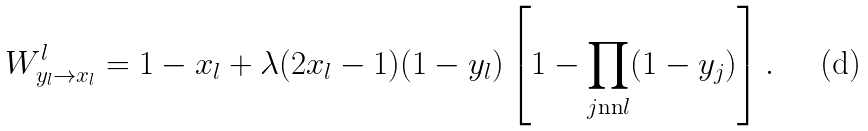<formula> <loc_0><loc_0><loc_500><loc_500>W _ { y _ { l } \rightarrow x _ { l } } ^ { l } = 1 - x _ { l } + \lambda ( 2 x _ { l } - 1 ) ( 1 - y _ { l } ) \left [ 1 - \prod _ { j \text {nn} l } ( 1 - y _ { j } ) \right ] .</formula> 